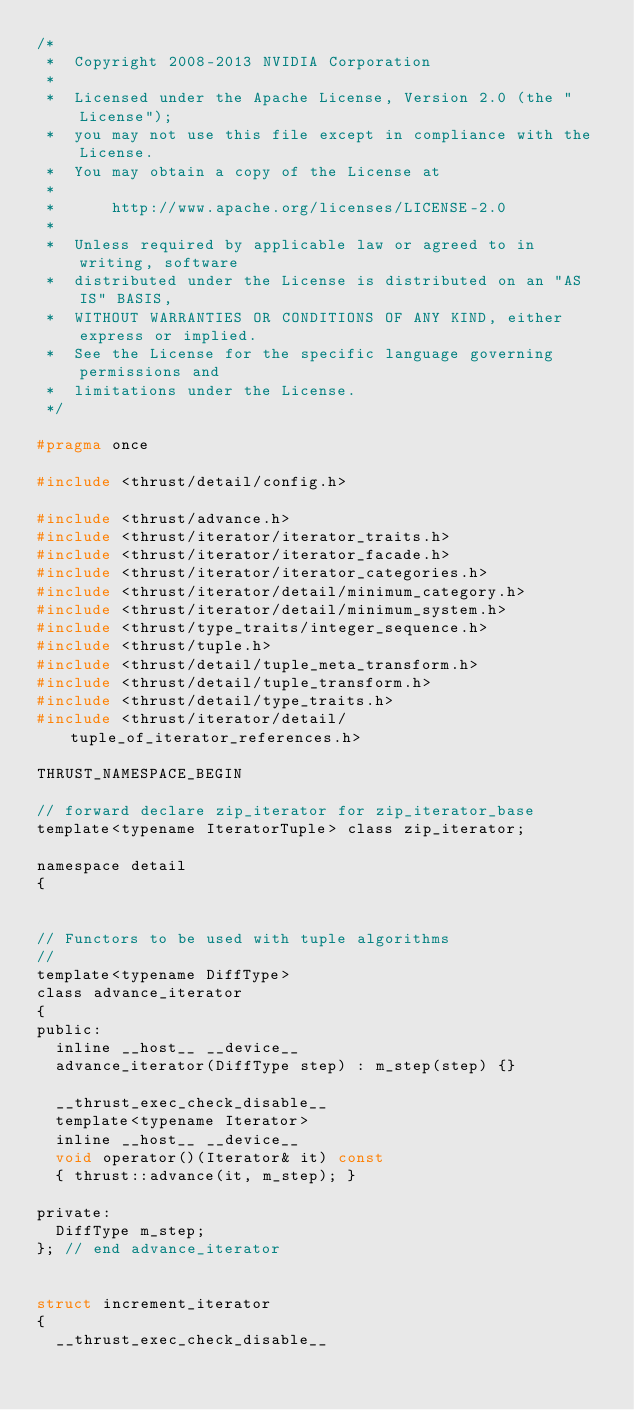<code> <loc_0><loc_0><loc_500><loc_500><_C_>/*
 *  Copyright 2008-2013 NVIDIA Corporation
 *
 *  Licensed under the Apache License, Version 2.0 (the "License");
 *  you may not use this file except in compliance with the License.
 *  You may obtain a copy of the License at
 *
 *      http://www.apache.org/licenses/LICENSE-2.0
 *
 *  Unless required by applicable law or agreed to in writing, software
 *  distributed under the License is distributed on an "AS IS" BASIS,
 *  WITHOUT WARRANTIES OR CONDITIONS OF ANY KIND, either express or implied.
 *  See the License for the specific language governing permissions and
 *  limitations under the License.
 */

#pragma once

#include <thrust/detail/config.h>

#include <thrust/advance.h>
#include <thrust/iterator/iterator_traits.h>
#include <thrust/iterator/iterator_facade.h>
#include <thrust/iterator/iterator_categories.h>
#include <thrust/iterator/detail/minimum_category.h>
#include <thrust/iterator/detail/minimum_system.h>
#include <thrust/type_traits/integer_sequence.h>
#include <thrust/tuple.h>
#include <thrust/detail/tuple_meta_transform.h>
#include <thrust/detail/tuple_transform.h>
#include <thrust/detail/type_traits.h>
#include <thrust/iterator/detail/tuple_of_iterator_references.h>

THRUST_NAMESPACE_BEGIN

// forward declare zip_iterator for zip_iterator_base
template<typename IteratorTuple> class zip_iterator;

namespace detail
{


// Functors to be used with tuple algorithms
//
template<typename DiffType>
class advance_iterator
{
public:
  inline __host__ __device__
  advance_iterator(DiffType step) : m_step(step) {}

  __thrust_exec_check_disable__
  template<typename Iterator>
  inline __host__ __device__
  void operator()(Iterator& it) const
  { thrust::advance(it, m_step); }

private:
  DiffType m_step;
}; // end advance_iterator


struct increment_iterator
{
  __thrust_exec_check_disable__</code> 